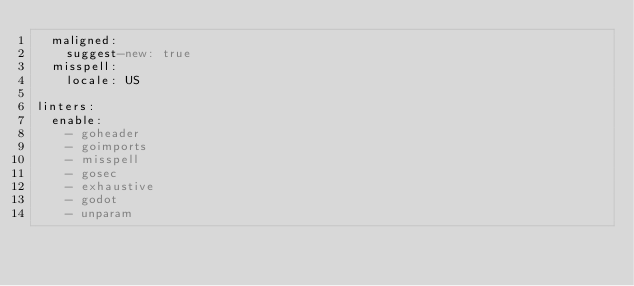Convert code to text. <code><loc_0><loc_0><loc_500><loc_500><_YAML_>  maligned:
    suggest-new: true
  misspell:
    locale: US

linters:
  enable:
    - goheader
    - goimports
    - misspell
    - gosec
    - exhaustive
    - godot
    - unparam</code> 